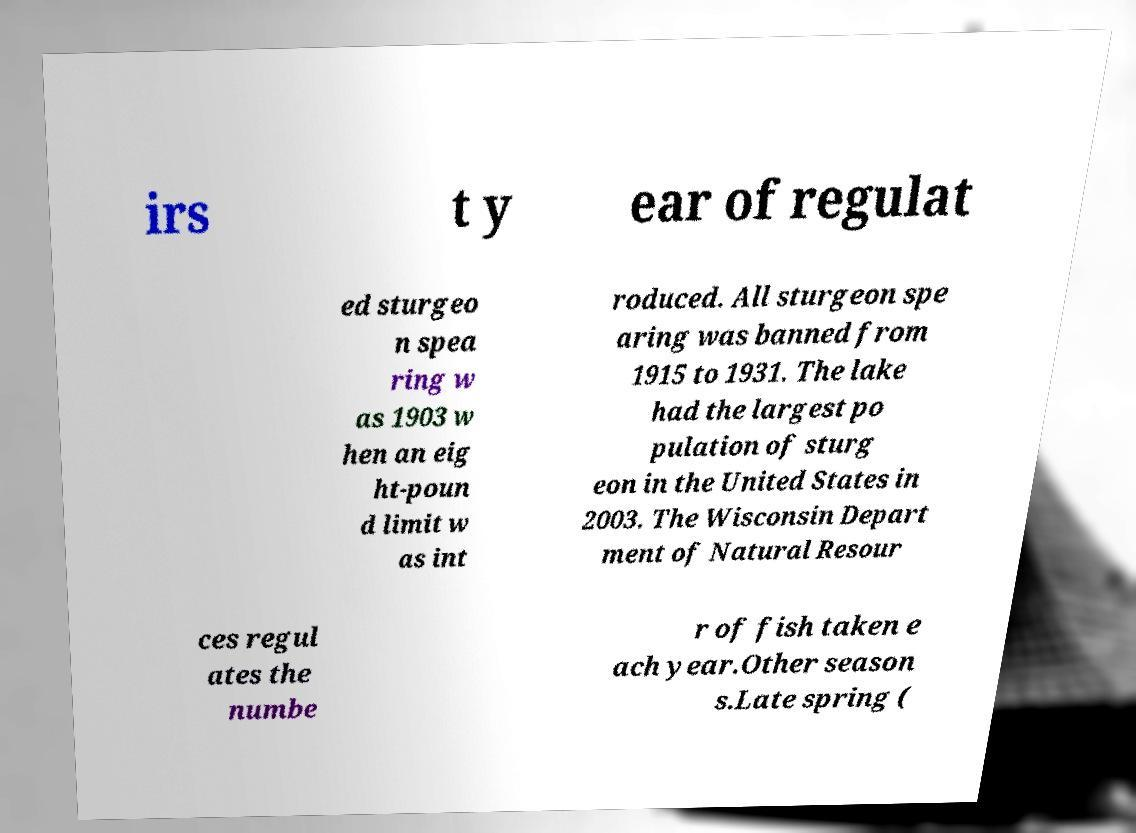What messages or text are displayed in this image? I need them in a readable, typed format. irs t y ear of regulat ed sturgeo n spea ring w as 1903 w hen an eig ht-poun d limit w as int roduced. All sturgeon spe aring was banned from 1915 to 1931. The lake had the largest po pulation of sturg eon in the United States in 2003. The Wisconsin Depart ment of Natural Resour ces regul ates the numbe r of fish taken e ach year.Other season s.Late spring ( 